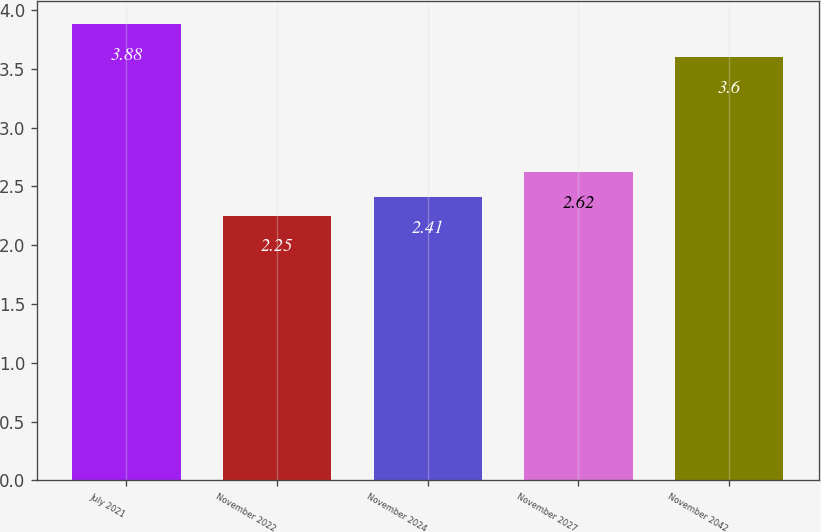<chart> <loc_0><loc_0><loc_500><loc_500><bar_chart><fcel>July 2021<fcel>November 2022<fcel>November 2024<fcel>November 2027<fcel>November 2042<nl><fcel>3.88<fcel>2.25<fcel>2.41<fcel>2.62<fcel>3.6<nl></chart> 